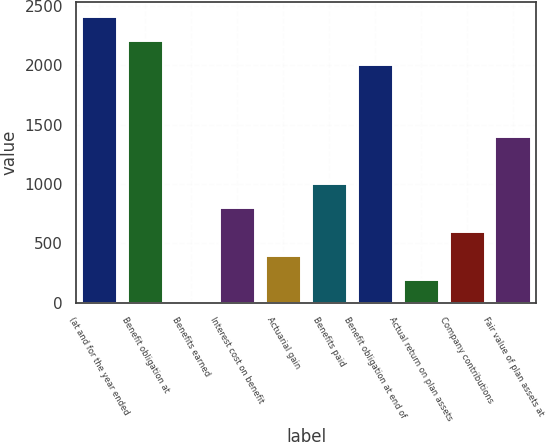Convert chart. <chart><loc_0><loc_0><loc_500><loc_500><bar_chart><fcel>(at and for the year ended<fcel>Benefit obligation at<fcel>Benefits earned<fcel>Interest cost on benefit<fcel>Actuarial gain<fcel>Benefits paid<fcel>Benefit obligation at end of<fcel>Actual return on plan assets<fcel>Company contributions<fcel>Fair value of plan assets at<nl><fcel>2410.6<fcel>2209.8<fcel>1<fcel>804.2<fcel>402.6<fcel>1005<fcel>2009<fcel>201.8<fcel>603.4<fcel>1406.6<nl></chart> 